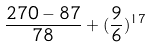<formula> <loc_0><loc_0><loc_500><loc_500>\frac { 2 7 0 - 8 7 } { 7 8 } + ( \frac { 9 } { 6 } ) ^ { 1 7 }</formula> 